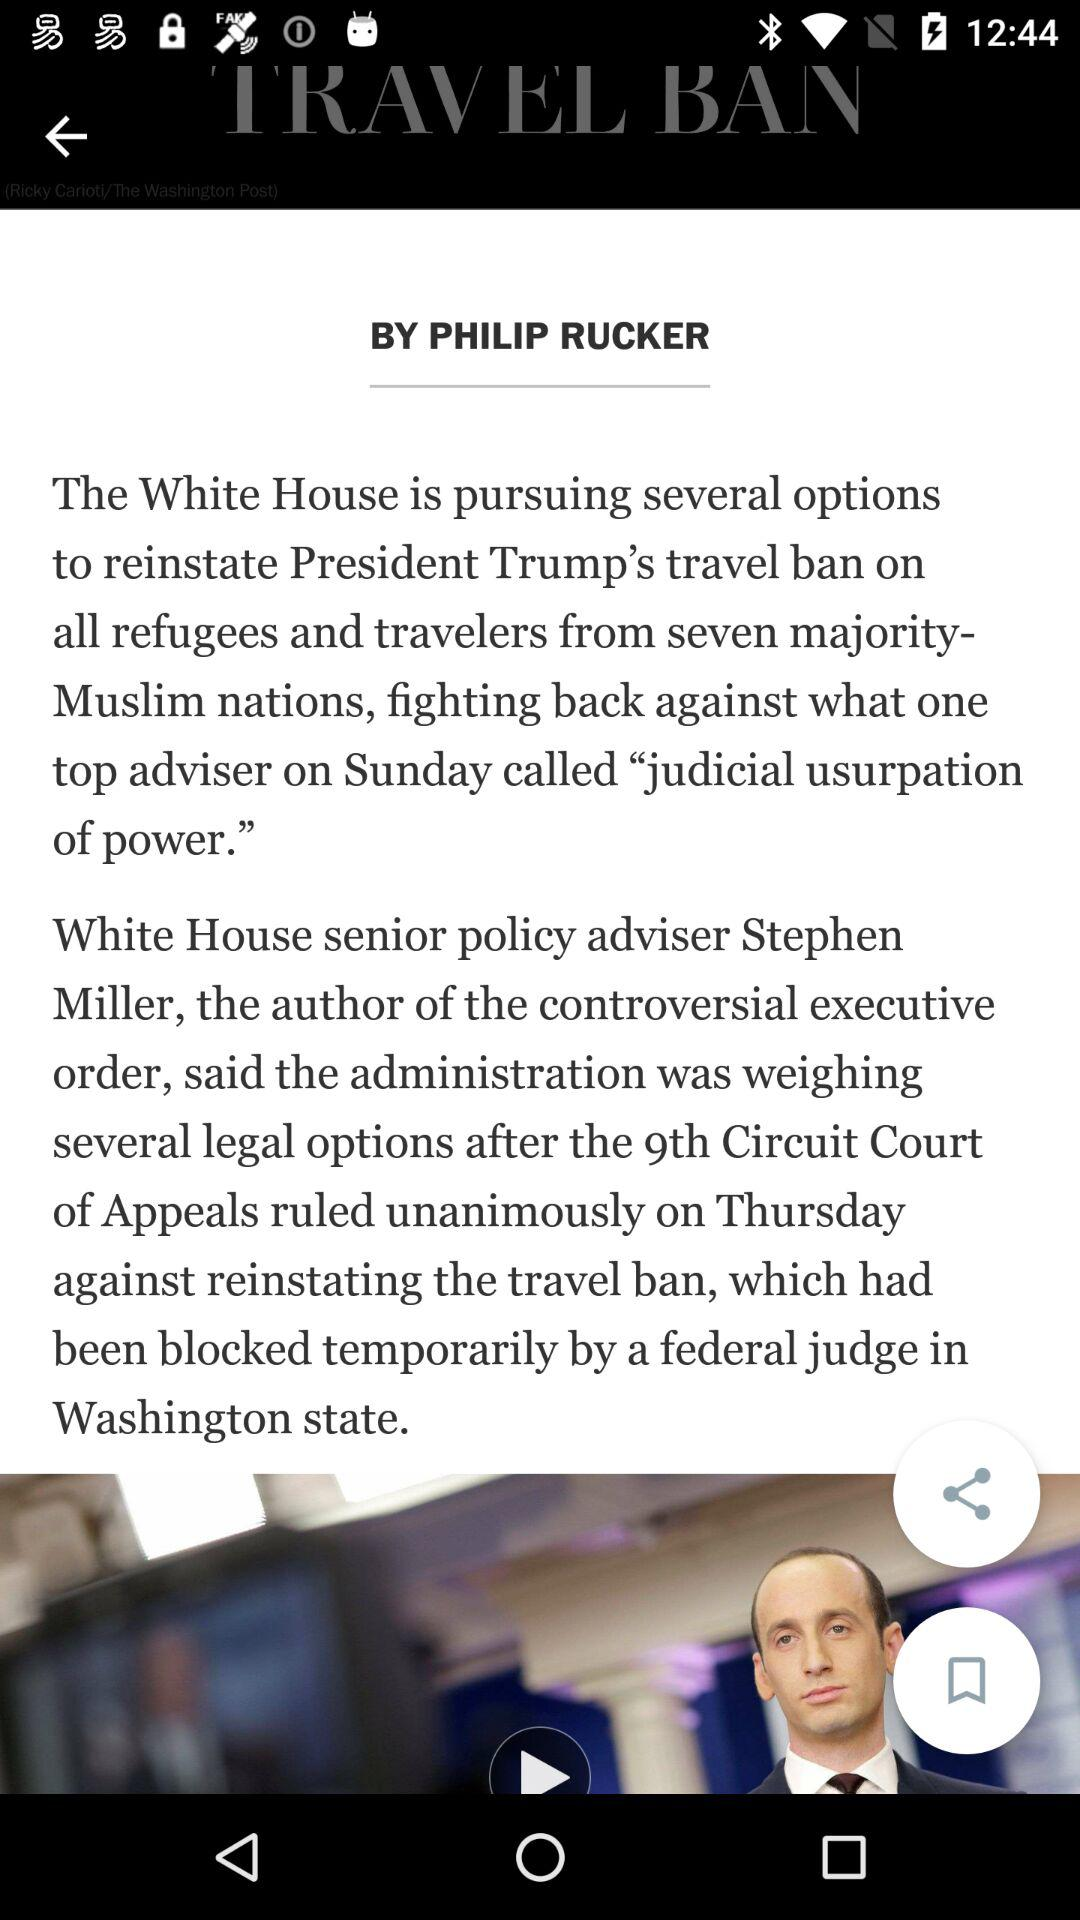Who is the author of the article? The author of the article is Philip Rucker. 